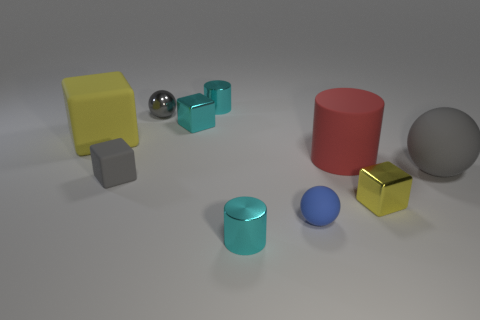What color is the tiny rubber object that is on the left side of the small cyan shiny cube?
Keep it short and to the point. Gray. There is a cylinder in front of the gray matte ball; is its size the same as the cyan object that is behind the shiny sphere?
Offer a terse response. Yes. What number of things are blue shiny things or big matte cylinders?
Make the answer very short. 1. What is the small gray thing on the left side of the sphere that is behind the big gray matte thing made of?
Give a very brief answer. Rubber. How many red objects are the same shape as the blue matte thing?
Keep it short and to the point. 0. Are there any metallic objects that have the same color as the matte cylinder?
Offer a terse response. No. How many objects are either gray balls that are right of the small rubber ball or small rubber things in front of the large ball?
Provide a succinct answer. 3. Is there a red rubber thing left of the cyan shiny object in front of the large gray matte ball?
Keep it short and to the point. No. There is a gray object that is the same size as the red matte thing; what shape is it?
Offer a terse response. Sphere. What number of things are tiny metallic cylinders behind the big yellow rubber object or gray cubes?
Keep it short and to the point. 2. 